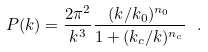<formula> <loc_0><loc_0><loc_500><loc_500>P ( k ) = \frac { 2 \pi ^ { 2 } } { k ^ { 3 } } \frac { ( k / k _ { 0 } ) ^ { n _ { 0 } } } { 1 + ( k _ { c } / k ) ^ { n _ { c } } } \ .</formula> 